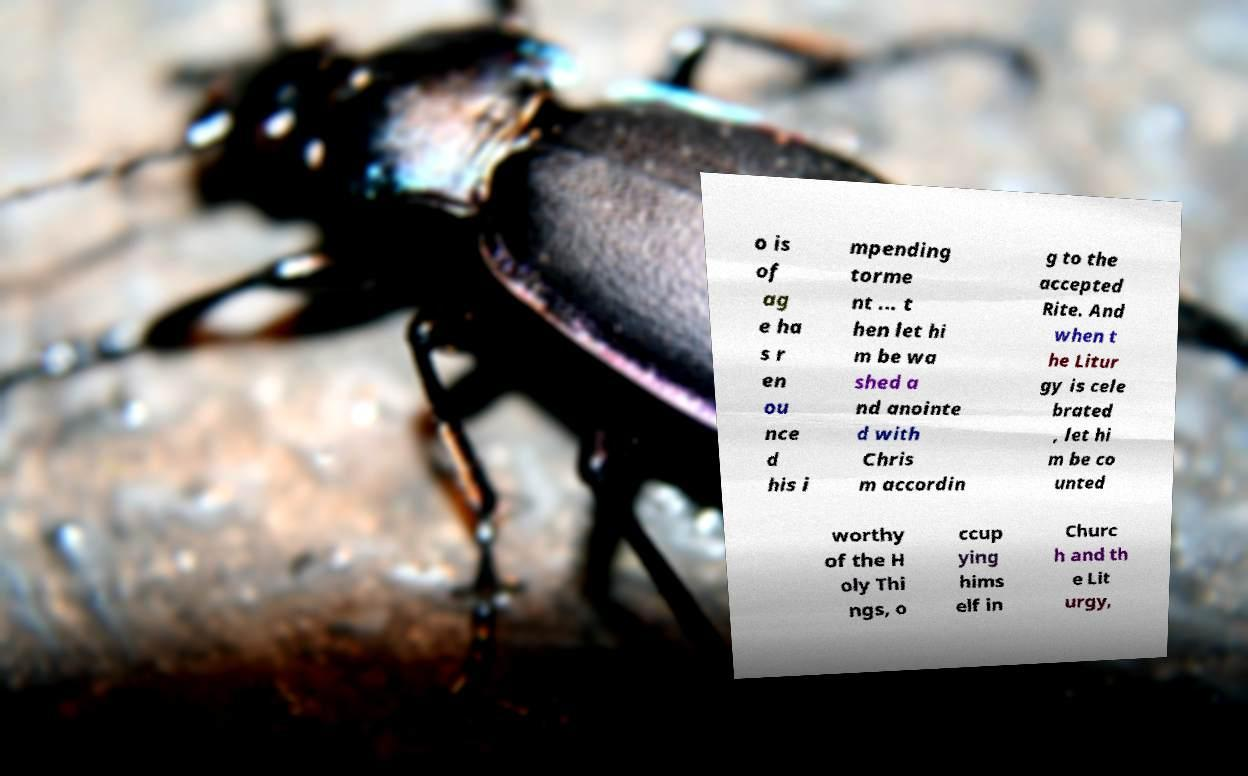Can you accurately transcribe the text from the provided image for me? o is of ag e ha s r en ou nce d his i mpending torme nt ... t hen let hi m be wa shed a nd anointe d with Chris m accordin g to the accepted Rite. And when t he Litur gy is cele brated , let hi m be co unted worthy of the H oly Thi ngs, o ccup ying hims elf in Churc h and th e Lit urgy, 